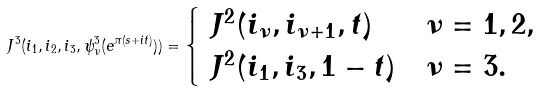<formula> <loc_0><loc_0><loc_500><loc_500>\ J ^ { 3 } ( i _ { 1 } , i _ { 2 } , i _ { 3 } , \psi ^ { 3 } _ { \nu } ( e ^ { \pi ( s + i t ) } ) ) = \begin{cases} \ J ^ { 2 } ( i _ { \nu } , i _ { \nu + 1 } , t ) & \nu = 1 , 2 , \\ \ J ^ { 2 } ( i _ { 1 } , i _ { 3 } , 1 - t ) & \nu = 3 . \end{cases}</formula> 